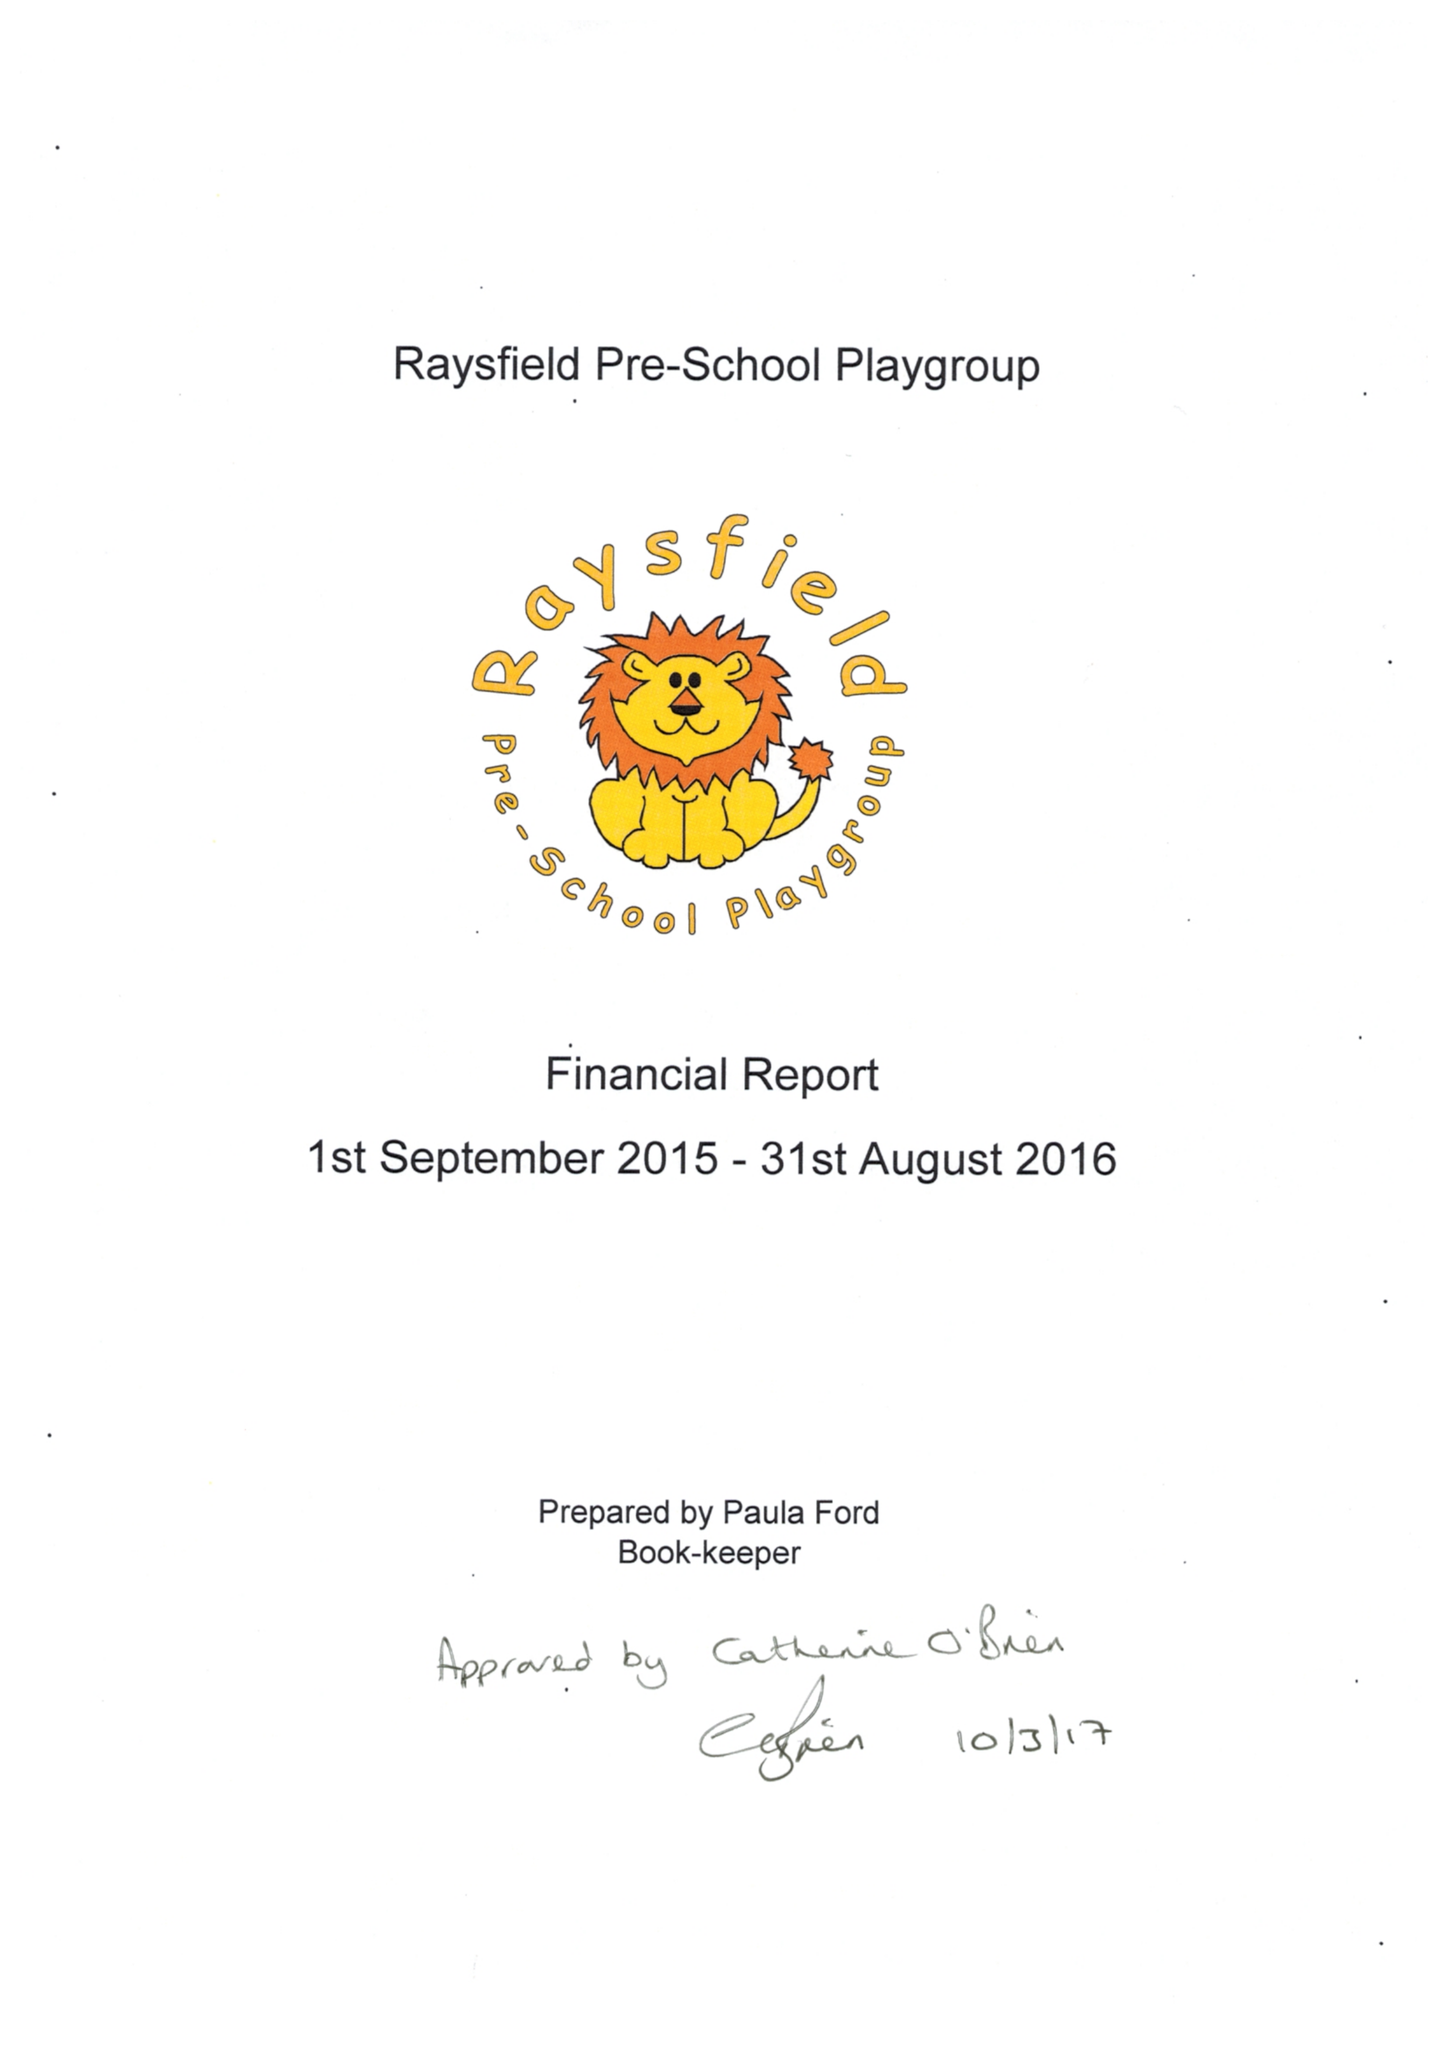What is the value for the report_date?
Answer the question using a single word or phrase. 2016-08-31 